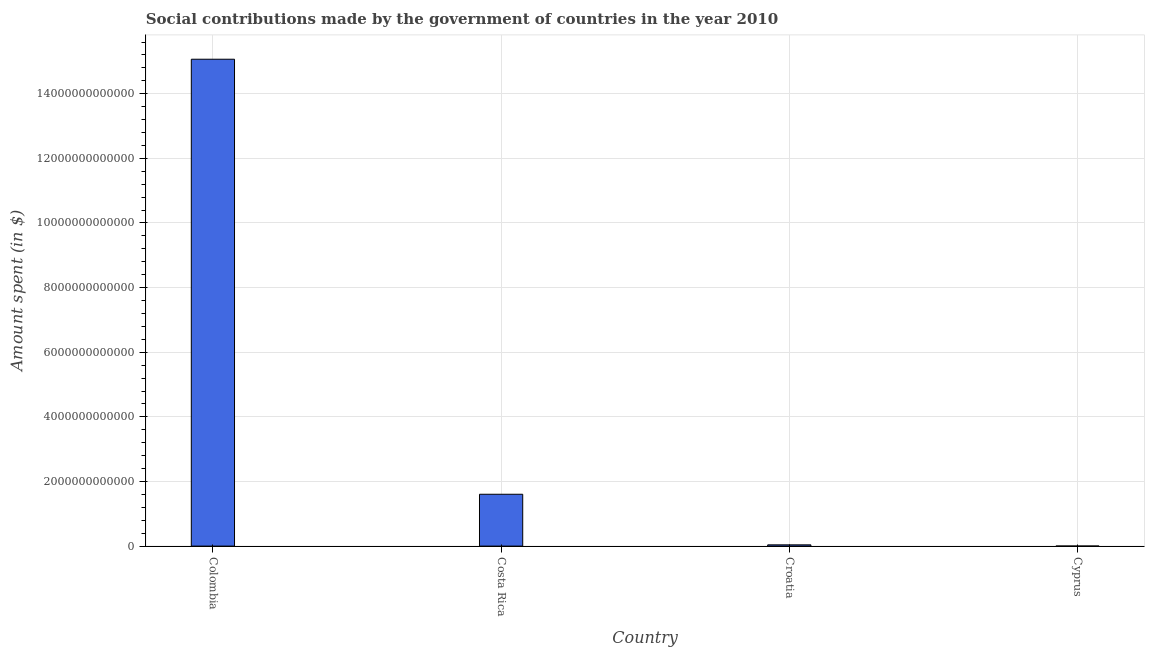What is the title of the graph?
Your response must be concise. Social contributions made by the government of countries in the year 2010. What is the label or title of the X-axis?
Your answer should be compact. Country. What is the label or title of the Y-axis?
Offer a very short reply. Amount spent (in $). What is the amount spent in making social contributions in Costa Rica?
Your answer should be compact. 1.60e+12. Across all countries, what is the maximum amount spent in making social contributions?
Keep it short and to the point. 1.51e+13. Across all countries, what is the minimum amount spent in making social contributions?
Provide a short and direct response. 1.55e+09. In which country was the amount spent in making social contributions minimum?
Keep it short and to the point. Cyprus. What is the sum of the amount spent in making social contributions?
Keep it short and to the point. 1.67e+13. What is the difference between the amount spent in making social contributions in Colombia and Cyprus?
Offer a terse response. 1.51e+13. What is the average amount spent in making social contributions per country?
Ensure brevity in your answer.  4.18e+12. What is the median amount spent in making social contributions?
Make the answer very short. 8.22e+11. What is the ratio of the amount spent in making social contributions in Colombia to that in Cyprus?
Offer a terse response. 9707.04. What is the difference between the highest and the second highest amount spent in making social contributions?
Your response must be concise. 1.35e+13. What is the difference between the highest and the lowest amount spent in making social contributions?
Keep it short and to the point. 1.51e+13. In how many countries, is the amount spent in making social contributions greater than the average amount spent in making social contributions taken over all countries?
Give a very brief answer. 1. Are all the bars in the graph horizontal?
Provide a succinct answer. No. What is the difference between two consecutive major ticks on the Y-axis?
Ensure brevity in your answer.  2.00e+12. Are the values on the major ticks of Y-axis written in scientific E-notation?
Your answer should be very brief. No. What is the Amount spent (in $) in Colombia?
Offer a terse response. 1.51e+13. What is the Amount spent (in $) in Costa Rica?
Provide a short and direct response. 1.60e+12. What is the Amount spent (in $) in Croatia?
Give a very brief answer. 3.87e+1. What is the Amount spent (in $) in Cyprus?
Your answer should be very brief. 1.55e+09. What is the difference between the Amount spent (in $) in Colombia and Costa Rica?
Give a very brief answer. 1.35e+13. What is the difference between the Amount spent (in $) in Colombia and Croatia?
Your answer should be compact. 1.50e+13. What is the difference between the Amount spent (in $) in Colombia and Cyprus?
Provide a short and direct response. 1.51e+13. What is the difference between the Amount spent (in $) in Costa Rica and Croatia?
Make the answer very short. 1.57e+12. What is the difference between the Amount spent (in $) in Costa Rica and Cyprus?
Provide a short and direct response. 1.60e+12. What is the difference between the Amount spent (in $) in Croatia and Cyprus?
Make the answer very short. 3.72e+1. What is the ratio of the Amount spent (in $) in Colombia to that in Costa Rica?
Provide a short and direct response. 9.39. What is the ratio of the Amount spent (in $) in Colombia to that in Croatia?
Your answer should be very brief. 389.24. What is the ratio of the Amount spent (in $) in Colombia to that in Cyprus?
Your answer should be very brief. 9707.04. What is the ratio of the Amount spent (in $) in Costa Rica to that in Croatia?
Make the answer very short. 41.45. What is the ratio of the Amount spent (in $) in Costa Rica to that in Cyprus?
Keep it short and to the point. 1033.7. What is the ratio of the Amount spent (in $) in Croatia to that in Cyprus?
Make the answer very short. 24.94. 